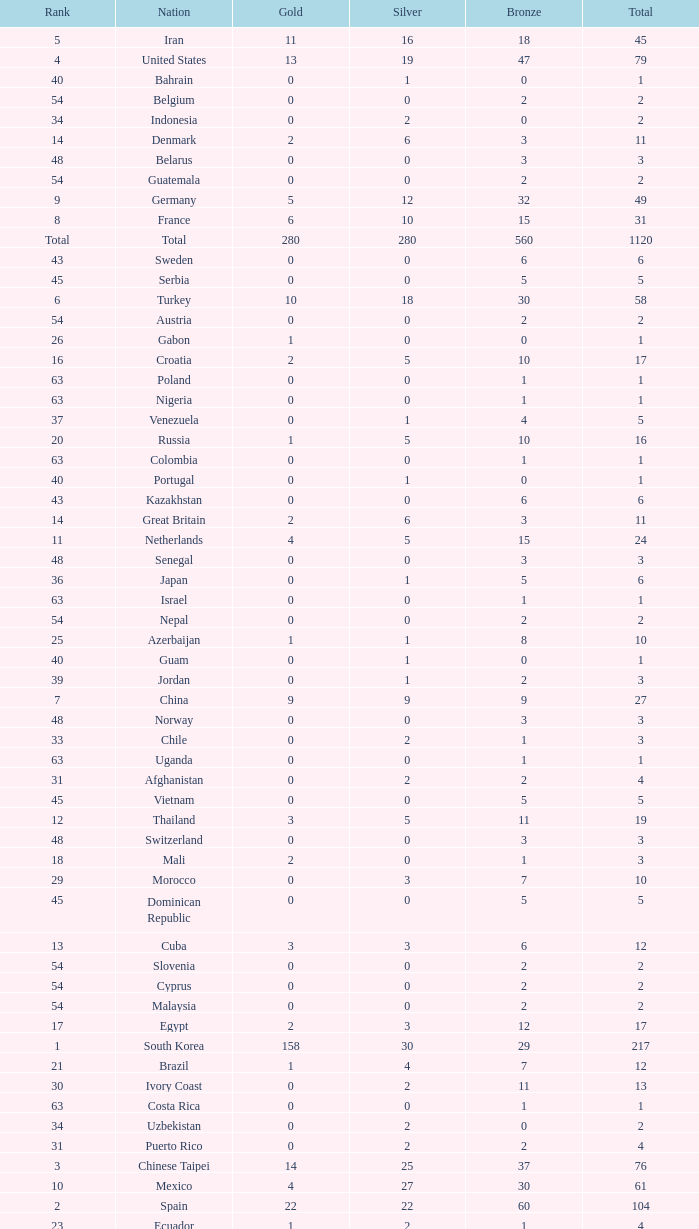What is the Total medals for the Nation ranking 33 with more than 1 Bronze? None. 